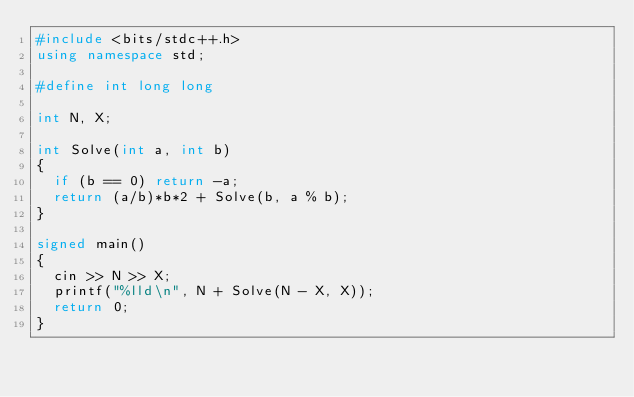<code> <loc_0><loc_0><loc_500><loc_500><_C++_>#include <bits/stdc++.h>
using namespace std;

#define int long long

int N, X;

int Solve(int a, int b)
{
	if (b == 0) return -a;
	return (a/b)*b*2 + Solve(b, a % b);
}

signed main()
{
	cin >> N >> X;
	printf("%lld\n", N + Solve(N - X, X));
	return 0;
}</code> 